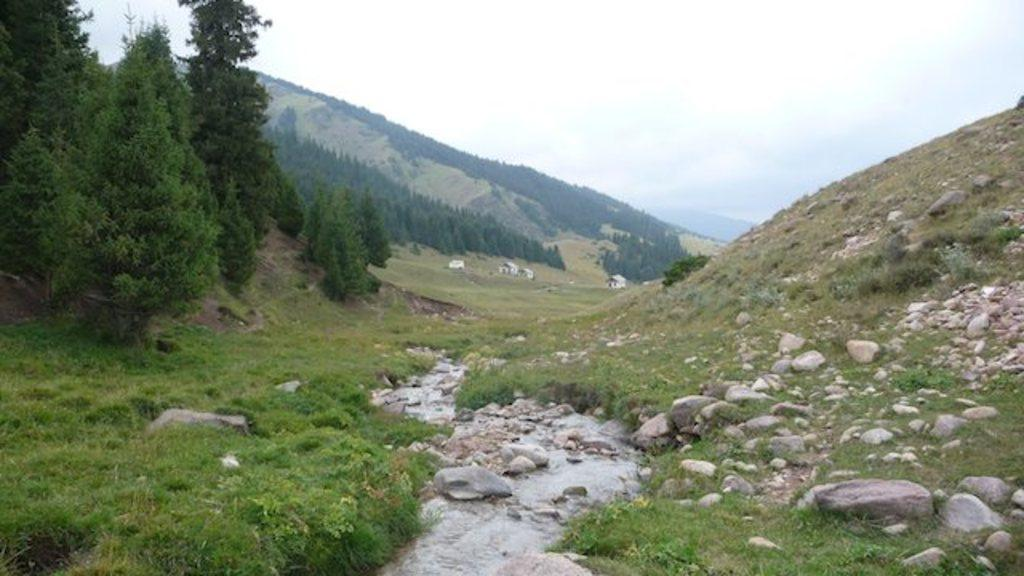What is at the bottom of the image? There is water at the bottom of the image. What type of vegetation can be seen in the image? There is grass and trees visible in the image. What kind of natural features are present in the image? Rocks and stones are present in the image. What can be seen in the background of the image? There are mountains in the background of the image. What is visible at the top of the image? The sky is visible at the top of the image. What type of prison can be seen in the image? There is no prison present in the image. How does the care for the trees affect the appearance of the image? There is no mention of care for the trees in the image, so it cannot be determined how it affects the appearance. 